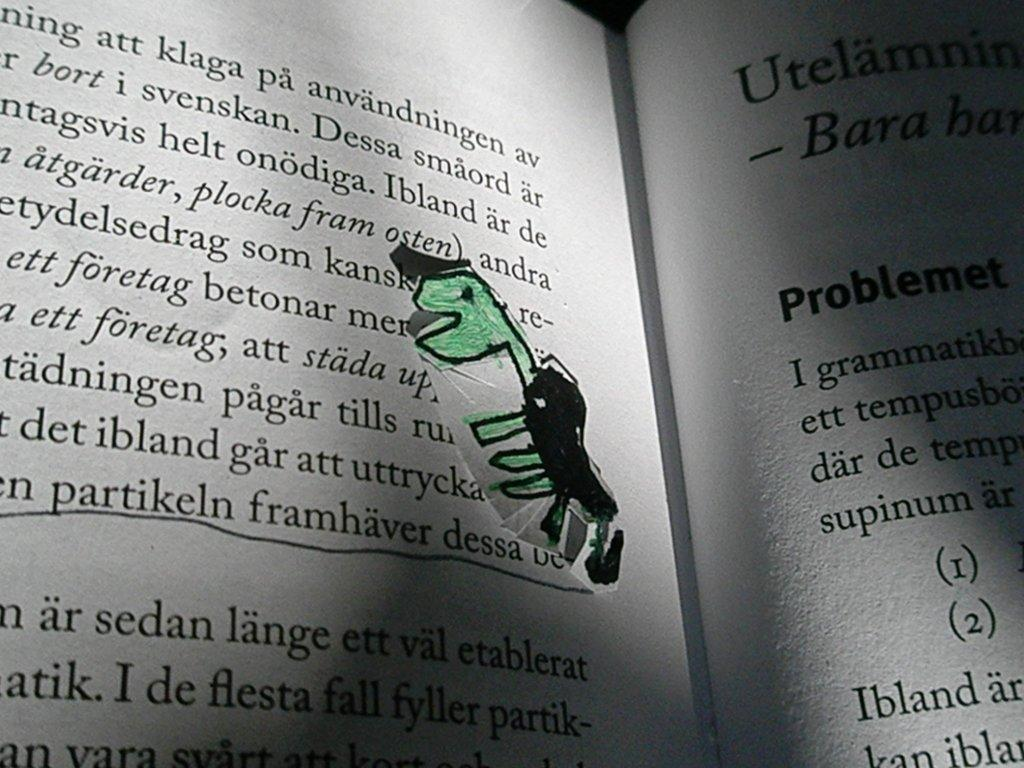<image>
Describe the image concisely. a hand drawn turtle bookmark is in a book that is not written in english 